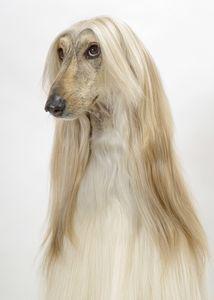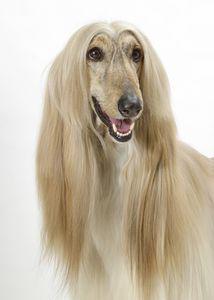The first image is the image on the left, the second image is the image on the right. Analyze the images presented: Is the assertion "The dog in the image on the right has a white coat." valid? Answer yes or no. No. 